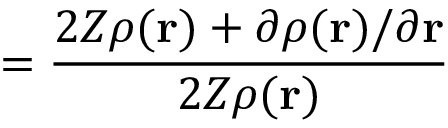<formula> <loc_0><loc_0><loc_500><loc_500>= \frac { 2 Z \rho ( r ) + \partial \rho ( r ) / \partial r } { 2 Z \rho ( r ) }</formula> 